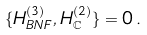Convert formula to latex. <formula><loc_0><loc_0><loc_500><loc_500>\{ H ^ { ( 3 ) } _ { B N F } , H ^ { ( 2 ) } _ { \mathbb { C } } \} = 0 \, .</formula> 